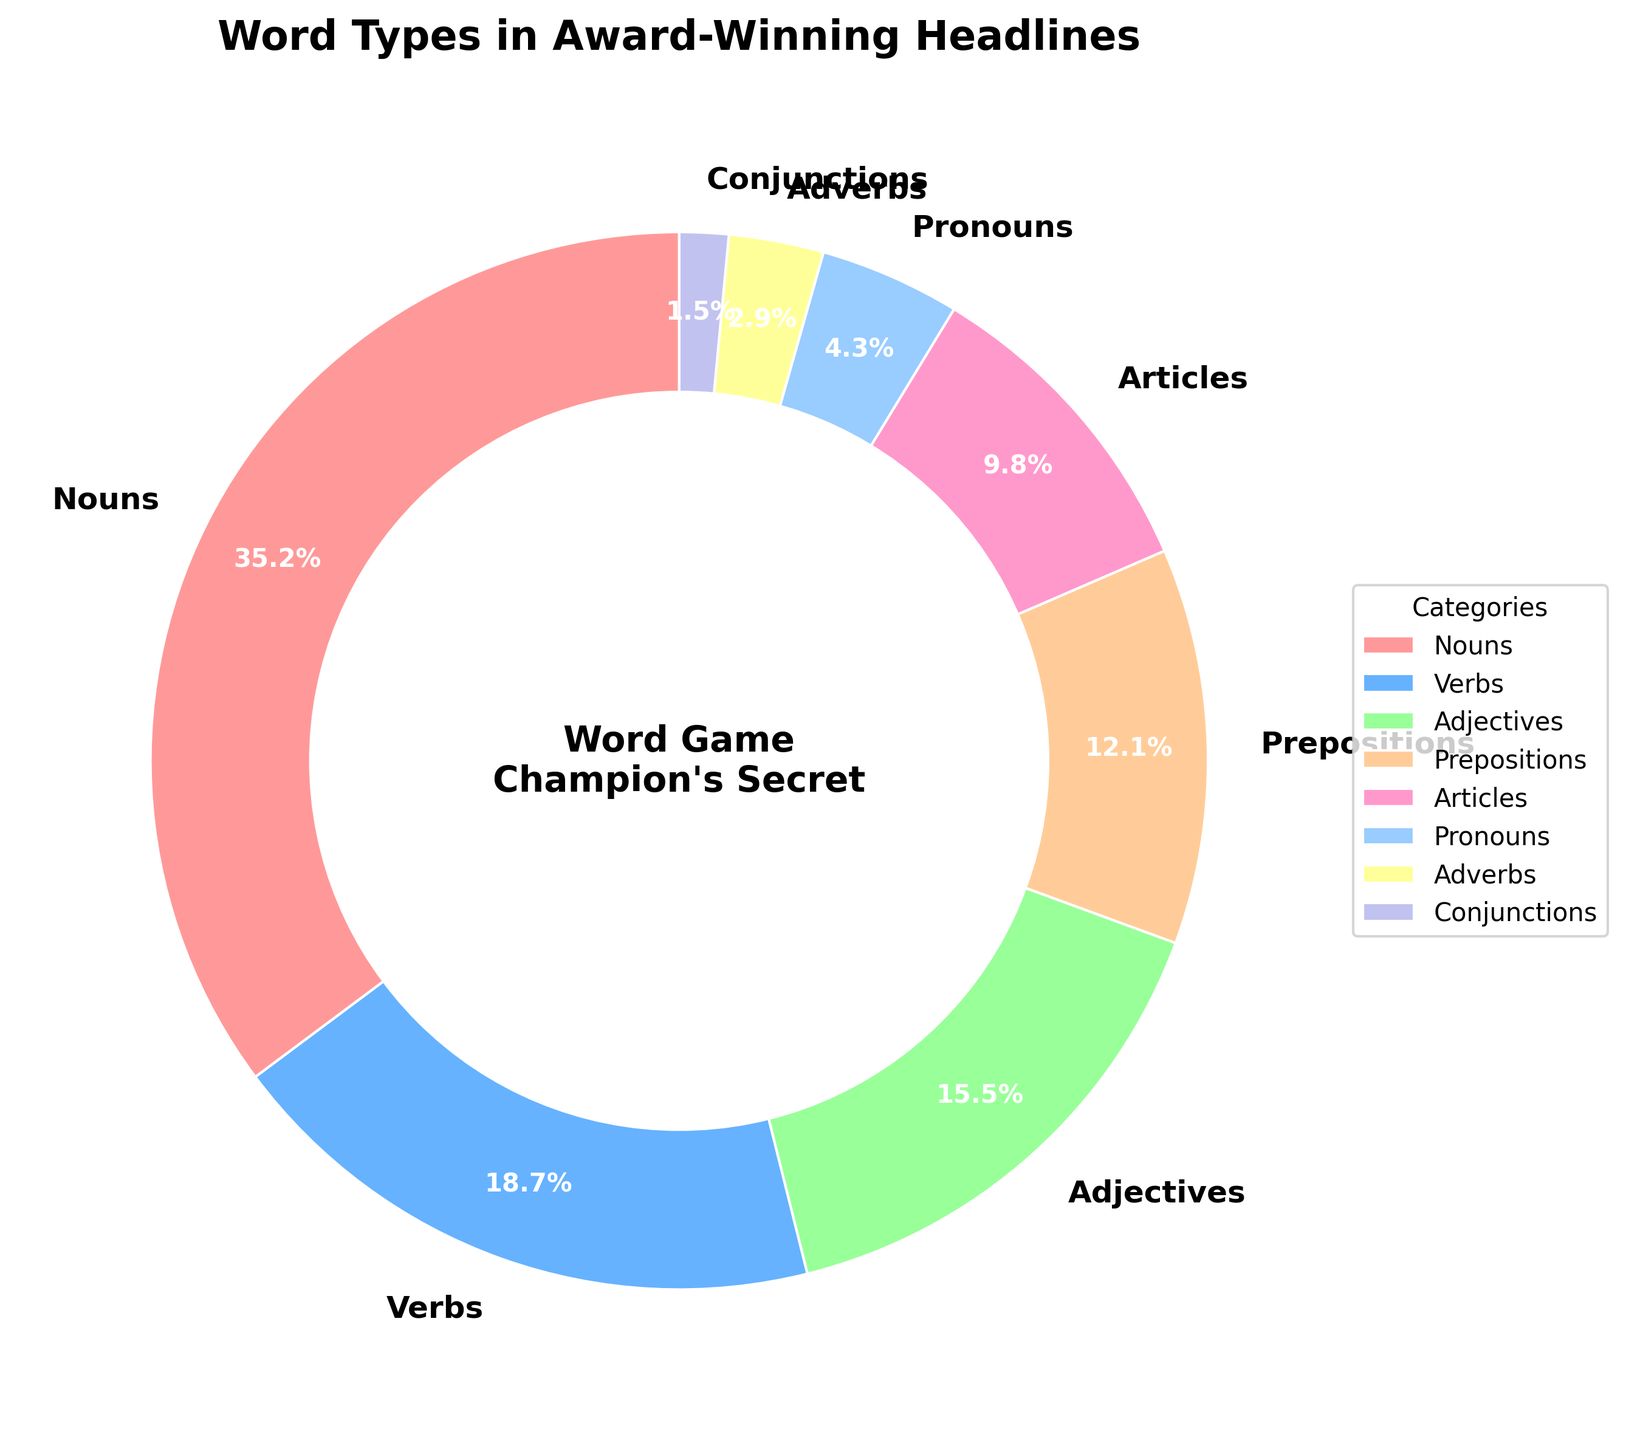Which word type is most frequently used in award-winning newspaper headlines? The segment with the highest percentage is the most frequently used word type. In this chart, Nouns have the highest percentage at 35.2%.
Answer: Nouns What is the combined percentage of Verbs and Adjectives in the headlines? To find the combined percentage, add the percentages of Verbs and Adjectives. Verbs: 18.7% + Adjectives: 15.5% = 34.2%.
Answer: 34.2% How does the usage of Articles compare to Pronouns in the headlines? The percentages for Articles and Pronouns are shown on the chart. Articles are 9.8% and Pronouns are 4.3%. Articles are used more frequently than Pronouns.
Answer: Articles are more frequent Which word types together make up more than half of the total percentage? Sum the percentages of the word types in descending order until the sum exceeds 50%. Nouns (35.2%) + Verbs (18.7%) = 53.9%. Nouns and Verbs together make up more than half.
Answer: Nouns and Verbs What is the difference in percentage between the least used and the most used word types? The most used word type is Nouns at 35.2%, and the least used is Conjunctions at 1.5%. The difference is: 35.2% - 1.5% = 33.7%.
Answer: 33.7% Which two word types, when combined, are closest to 25% of the total, but do not exceed it? Evaluate combinations of percentages to find those closest to 25% without exceeding it. Articles (9.8%) + Adverbs (2.9%) = 12.7%. Articles + Pronouns (4.3%) = 14.1%. Articles (9.8%) + Prepositions (12.1%) = 21.9%, which is closest.
Answer: Articles and Prepositions Among the visual elements, what color represents the category with the second highest percentage? Look at the color of the segment with the second largest percentage. The second largest slice is Verbs at 18.7%, represented by blue.
Answer: Blue What is the ratio of Adjectives to Nouns in the headlines? To find the ratio, divide the percentage of Adjectives by the percentage of Nouns. Adjectives (15.5%) / Nouns (35.2%) = 0.44 (approximately).
Answer: 0.44 If Adjectives and Adverbs are combined, what fraction of the total percentage do they represent? Add the percentages for Adjectives and Adverbs and convert to a fraction of 100. Adjectives (15.5%) + Adverbs (2.9%) = 18.4%, which is 18.4/100 or 0.184.
Answer: 0.184 Are there more Prepositions or Pronouns used in the headlines? Compare the percentages of Prepositions and Pronouns. Prepositions are 12.1%, and Pronouns are 4.3%. Prepositions are more frequently used.
Answer: Prepositions 